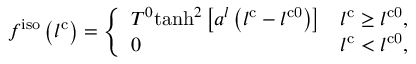Convert formula to latex. <formula><loc_0><loc_0><loc_500><loc_500>f ^ { i s o } \left ( l ^ { c } \right ) = \left \{ \begin{array} { l l } { T ^ { 0 } t a n h ^ { 2 } \left [ a ^ { l } \left ( l ^ { c } - l ^ { c 0 } \right ) \right ] } & { l ^ { c } \geq l ^ { c 0 } , } \\ { 0 } & { l ^ { c } < l ^ { c 0 } , } \end{array}</formula> 